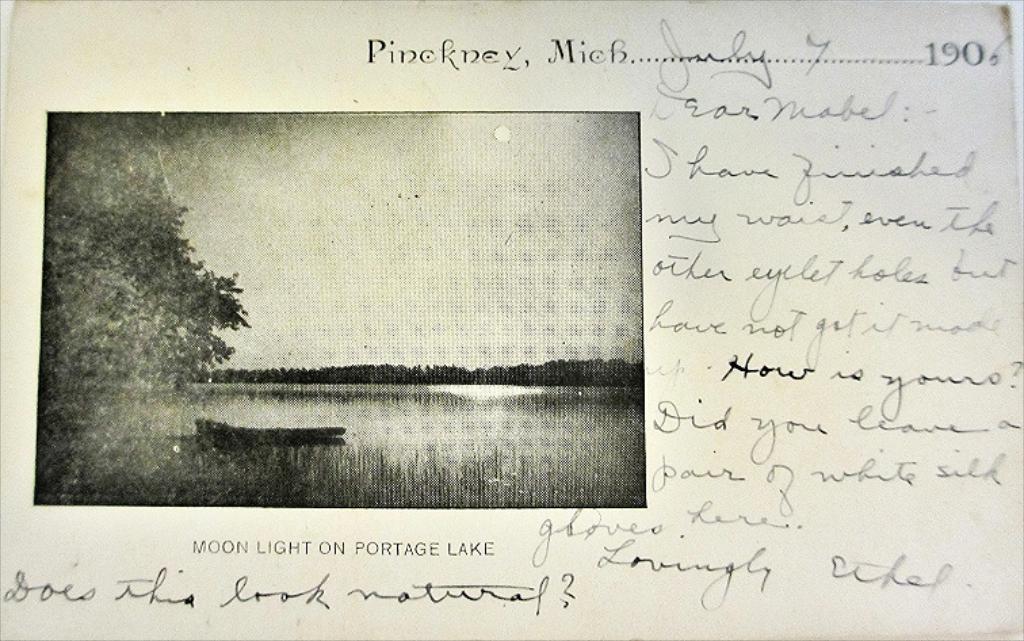Describe this image in one or two sentences. In this image there is one paper on the right side there is text, and on the left side there is one photo and in the photo there is one boat, sea and some trees sky and sun. 